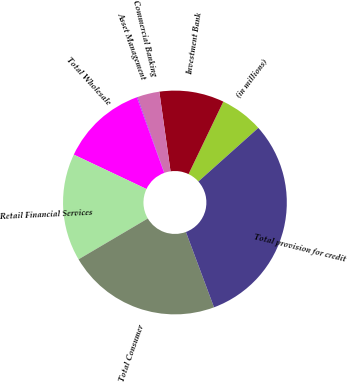Convert chart to OTSL. <chart><loc_0><loc_0><loc_500><loc_500><pie_chart><fcel>(in millions)<fcel>Investment Bank<fcel>Commercial Banking<fcel>Asset Management<fcel>Total Wholesale<fcel>Retail Financial Services<fcel>Total Consumer<fcel>Total provision for credit<nl><fcel>6.27%<fcel>9.35%<fcel>3.19%<fcel>0.11%<fcel>12.44%<fcel>15.52%<fcel>22.2%<fcel>30.93%<nl></chart> 